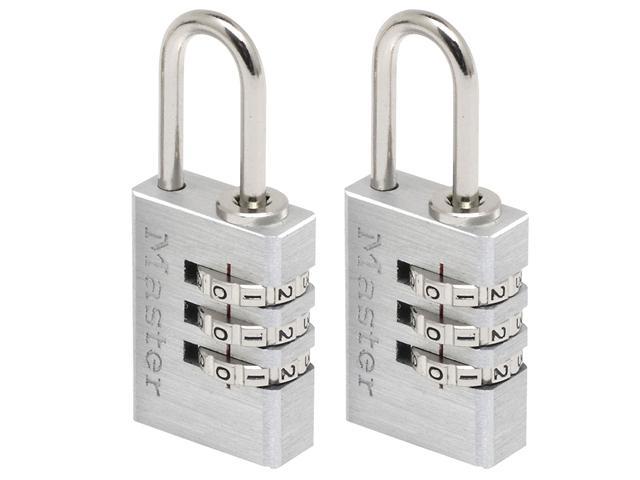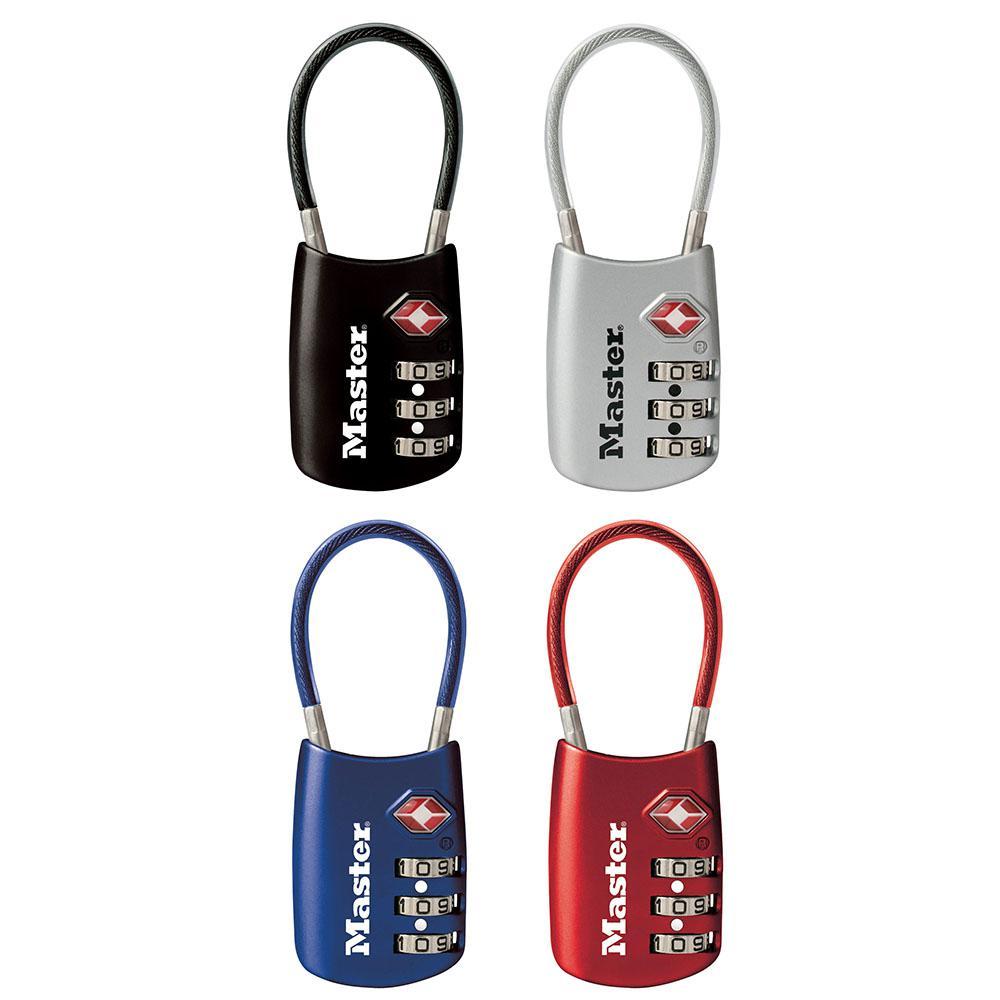The first image is the image on the left, the second image is the image on the right. Examine the images to the left and right. Is the description "Only one of the locks are mostly black in color." accurate? Answer yes or no. Yes. 